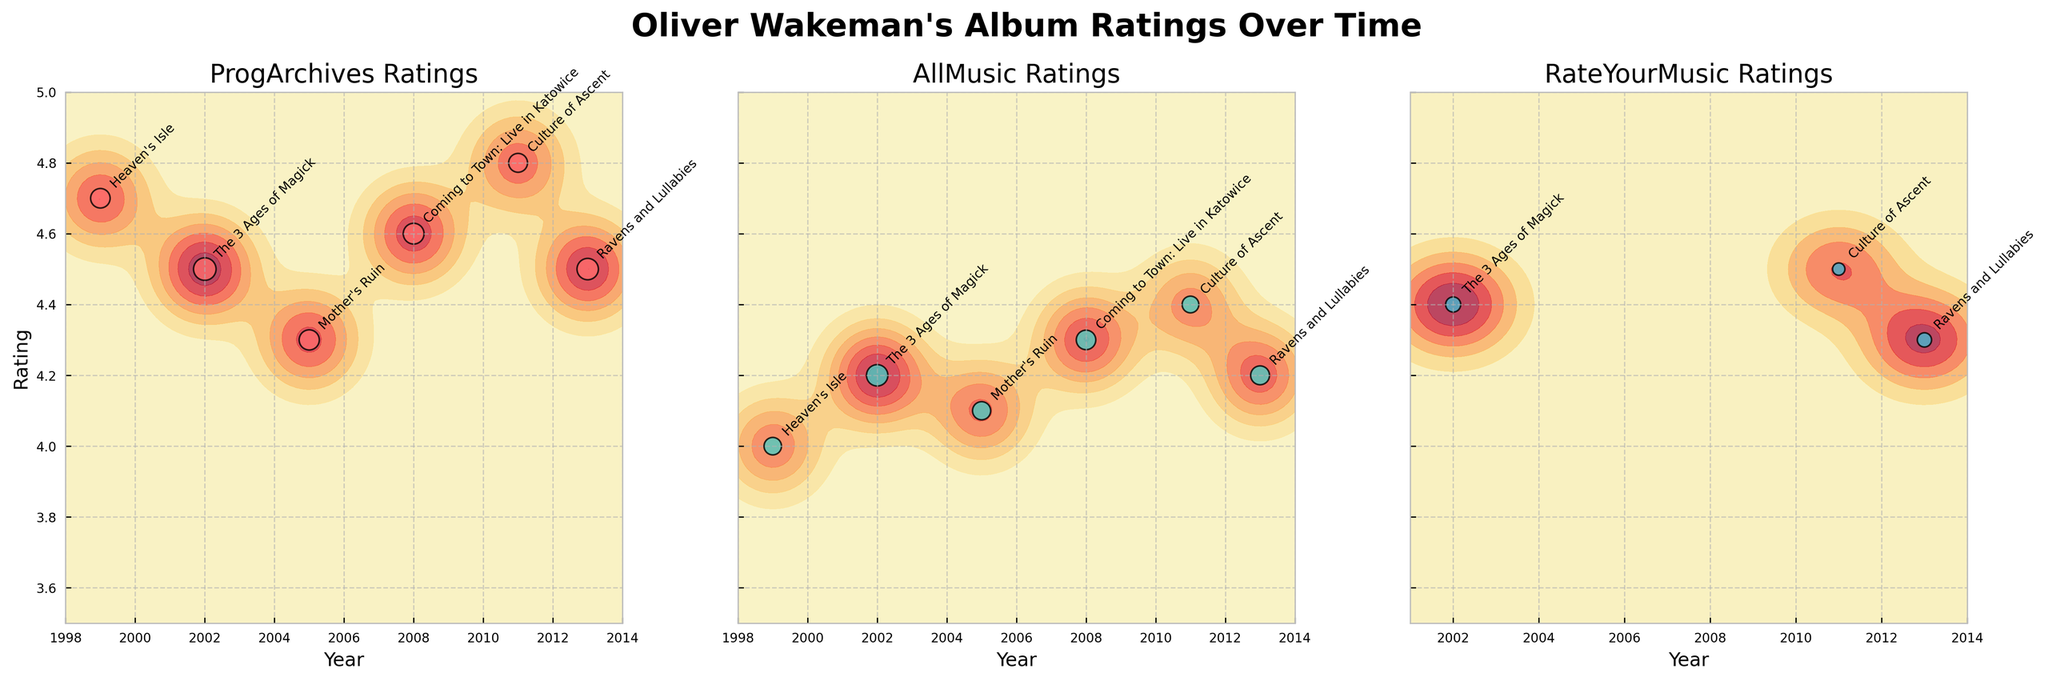What is the title of the figure? The title is displayed at the top center of the figure and reads "Oliver Wakeman's Album Ratings Over Time".
Answer: "Oliver Wakeman's Album Ratings Over Time" Which album received the highest rating on ProgArchives? The highest rating on ProgArchives is at the top of the y-axis with a value of 4.8. Cross-referencing the annotated labels near this rating point shows the album "Culture of Ascent" received a rating of 4.8.
Answer: "Culture of Ascent" In which year does "The 3 Ages of Magick" appear, and what is its rating on RateYourMusic? Locate the album "The 3 Ages of Magick" by looking at the annotated labels for RateYourMusic. The label indicates the year 2002 and the rating appears in the y-axis coordinates as 4.4.
Answer: 2002 and 4.4 How did the ratings for "Ravens and Lullabies" change between ProgArchives and AllMusic? Identify the entries for "Ravens and Lullabies" on both ProgArchives and AllMusic by checking the annotated labels. On ProgArchives, the rating is 4.5 and on AllMusic, it is 4.2. The difference is found by subtracting 4.2 from 4.5 which is 0.3.
Answer: Decreased by 0.3 Which review source shows the highest concentration of high ratings (above 4.5) over time? Examine all three subplots for areas with contour levels indicating high concentrations around ratings above 4.5. ProgArchives shows frequent and dense higher ratings on the y-axis above 4.5 across multiple years.
Answer: ProgArchives What is the overall trend for Oliver Wakeman's album ratings from 1999 to 2013 as displayed in the subplots? Look at the x-axis for a general trend line from the left (1999) to the right (2013). All three subplots show high ratings consistently around or above 4.0, indicating a trend of maintaining high ratings over time.
Answer: Consistently high ratings Are there more albums with higher ratings and review counts in the earlier or later years? Compare the density and counting of data points (scatter sizes) on each subplot from the far left (earlier years) to the right (later years). The spread of larger-sized points appears more in the later years, especially from 2002 onwards.
Answer: Later years How does "Mother's Ruin" compare across the different review sources in terms of ratings? Check the annotated labels for "Mother's Ruin" in each subplot. The ratings are as follows: ProgArchives (4.3), AllMusic (4.1). The comparison shows slight variations in ratings across sources.
Answer: ProgArchives (4.3), AllMusic (4.1) What album and year received the lowest rating and on which review source? Identify the lowest rating point on the y-axis for each subplot. The lowest rating value is found on AllMusic for the album "Heaven's Isle" in 1999, which is a rating of 4.0.
Answer: "Heaven's Isle", 1999 on AllMusic 